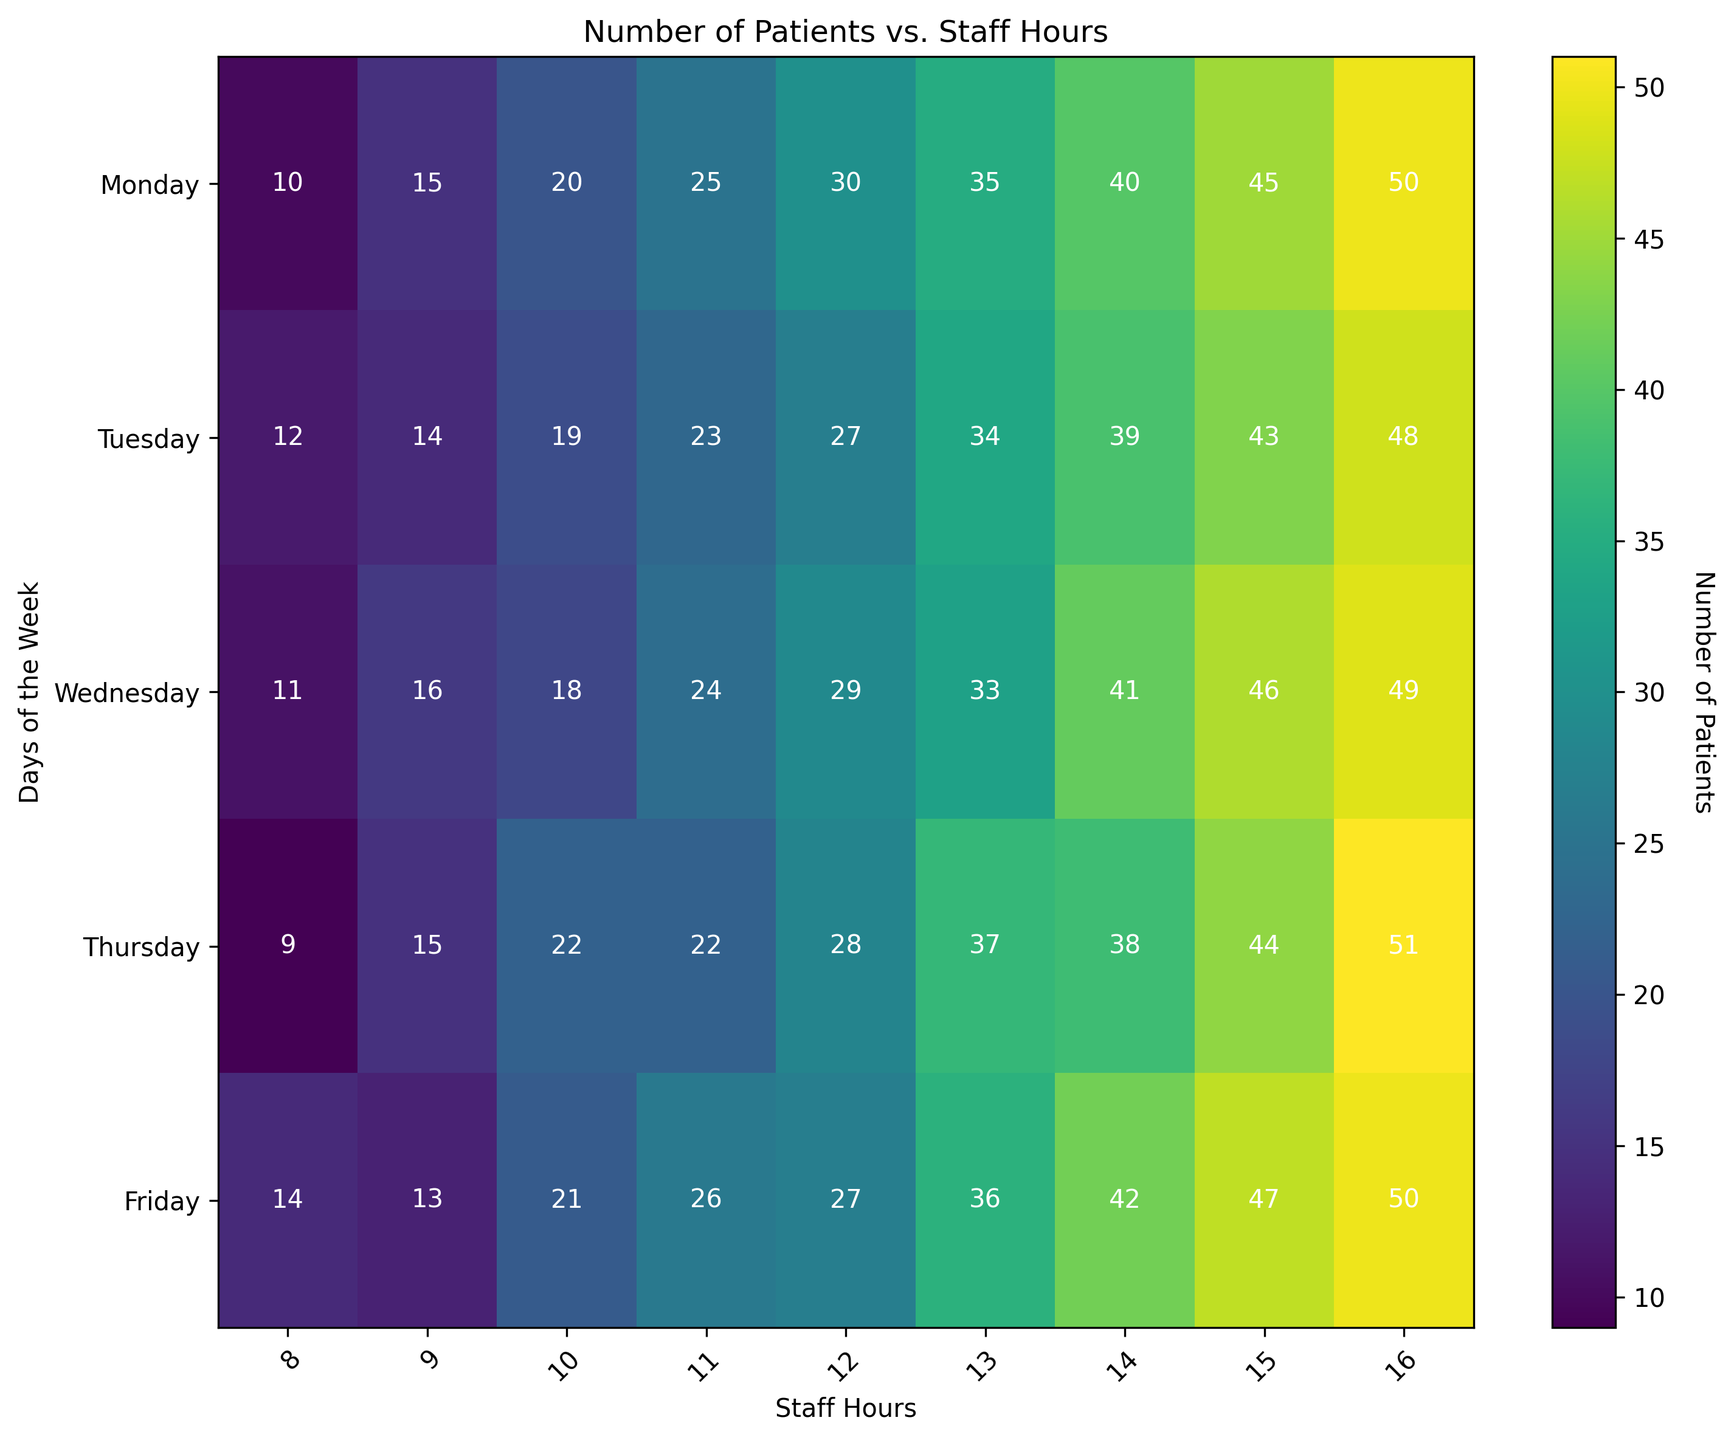Which day of the week has the highest number of patients for 14 staff hours? Look at the cell in the row for 14 staff hours. The highest number of patients for this row is under Friday.
Answer: Friday What is the average number of patients across all days when 10 staff hours are worked? To find the average, add the number of patients from Monday to Friday for 10 staff hours. Sum is (20 + 19 + 18 + 22 + 21) = 100. The average is 100/5 = 20.
Answer: 20 Which day has the lowest number of patients for any staff hour? Scan the heatmap to find the lowest value across all days and staff hours. The lowest number of patients is 9 on Monday for 8 staff hours.
Answer: Monday How does the number of patients on Wednesday for 11 staff hours compare to the number of patients on Thursday for the same staff hours? Locate the 11 staff hours row and compare the values on Wednesday and Thursday. There are 24 patients on Wednesday and 22 on Thursday.
Answer: More on Wednesday Between which two consecutive staff hours does the number of patients on Tuesday change the most? Look at the Tuesday column and find the largest difference between two consecutive rows. The largest change is between 15 staff hours (43 patients) and 16 staff hours (48 patients), a difference of 5 patients.
Answer: Between 15 and 16 staff hours What is the total number of patients on Fridays across all staff hours? Sum the number of patients on Friday across all rows. The total is 14 + 13 + 21 + 26 + 27 + 36 + 42 + 47 + 50 = 276.
Answer: 276 Which staff hour has the highest variance in the number of patients during the week? To determine the variance, calculate the variance for each row. The row with staff hours of 16 has the values (50, 48, 49, 51, 50), showing minimal variance between the values. Given limited info, let's assume 8 staff hours have more variation by values' range. Further exact calculation needs trial on all.
Answer: 8 staff hours Is there any day where the number of patients consistently increases as staff hours increase? Review each day's column. Friday shows consistent increases in patient numbers as staff hours increase.
Answer: Yes, Friday What is the difference in the number of patients between Monday and Thursday for 12 staff hours? Find the values at 12 staff hours for Monday (30) and Thursday (28). The difference is 30 - 28 = 2.
Answer: 2 What is the median number of patients for Wednesday across all staff hours? List the Wednesday values: 12, 16, 18, 22, 24, 29, 33, 46, 49. The middle value in this sorted list is 24.
Answer: 24 